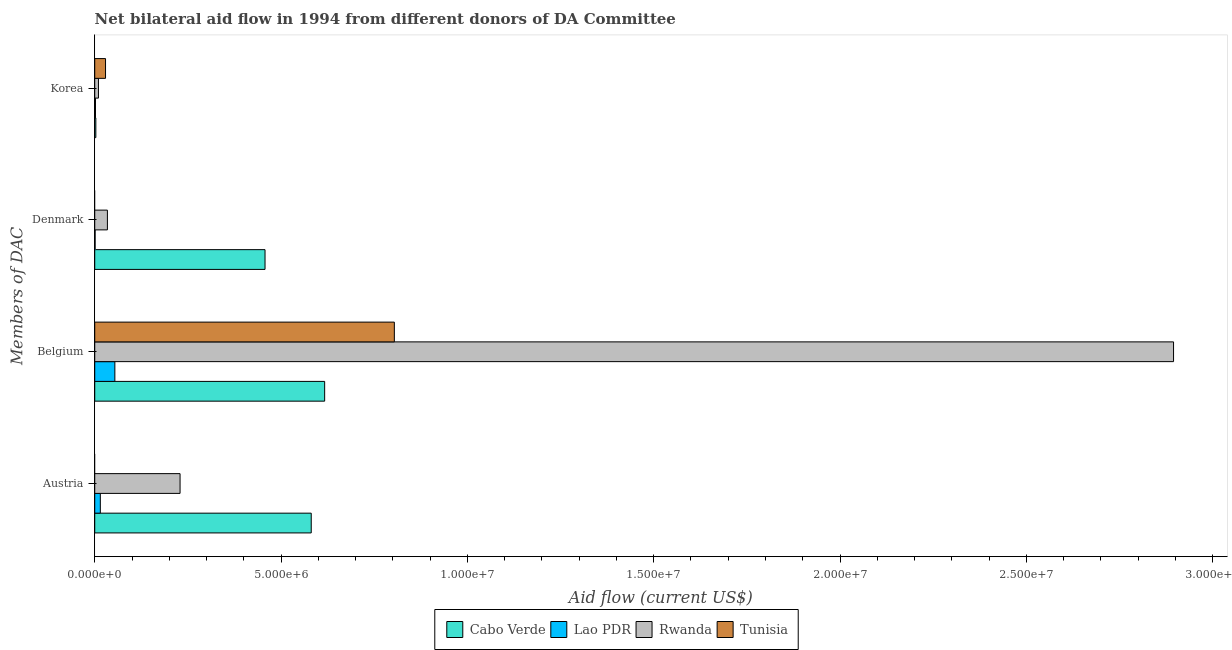Are the number of bars per tick equal to the number of legend labels?
Ensure brevity in your answer.  No. How many bars are there on the 3rd tick from the top?
Give a very brief answer. 4. How many bars are there on the 3rd tick from the bottom?
Offer a terse response. 3. What is the label of the 1st group of bars from the top?
Your answer should be compact. Korea. What is the amount of aid given by korea in Tunisia?
Provide a short and direct response. 2.90e+05. Across all countries, what is the maximum amount of aid given by austria?
Give a very brief answer. 5.81e+06. Across all countries, what is the minimum amount of aid given by denmark?
Make the answer very short. 0. In which country was the amount of aid given by austria maximum?
Offer a very short reply. Cabo Verde. What is the total amount of aid given by denmark in the graph?
Provide a short and direct response. 4.92e+06. What is the difference between the amount of aid given by korea in Rwanda and that in Tunisia?
Keep it short and to the point. -1.90e+05. What is the difference between the amount of aid given by austria in Lao PDR and the amount of aid given by korea in Tunisia?
Keep it short and to the point. -1.40e+05. What is the average amount of aid given by denmark per country?
Give a very brief answer. 1.23e+06. What is the difference between the amount of aid given by denmark and amount of aid given by belgium in Cabo Verde?
Ensure brevity in your answer.  -1.60e+06. What is the ratio of the amount of aid given by korea in Cabo Verde to that in Lao PDR?
Ensure brevity in your answer.  1.5. What is the difference between the highest and the second highest amount of aid given by denmark?
Provide a succinct answer. 4.23e+06. What is the difference between the highest and the lowest amount of aid given by austria?
Your response must be concise. 5.81e+06. In how many countries, is the amount of aid given by korea greater than the average amount of aid given by korea taken over all countries?
Offer a terse response. 1. How many bars are there?
Your response must be concise. 14. Are the values on the major ticks of X-axis written in scientific E-notation?
Keep it short and to the point. Yes. Does the graph contain any zero values?
Offer a very short reply. Yes. Does the graph contain grids?
Offer a terse response. No. Where does the legend appear in the graph?
Your response must be concise. Bottom center. How many legend labels are there?
Keep it short and to the point. 4. What is the title of the graph?
Your response must be concise. Net bilateral aid flow in 1994 from different donors of DA Committee. Does "Chile" appear as one of the legend labels in the graph?
Offer a terse response. No. What is the label or title of the X-axis?
Provide a short and direct response. Aid flow (current US$). What is the label or title of the Y-axis?
Your answer should be compact. Members of DAC. What is the Aid flow (current US$) of Cabo Verde in Austria?
Your answer should be very brief. 5.81e+06. What is the Aid flow (current US$) of Lao PDR in Austria?
Provide a succinct answer. 1.50e+05. What is the Aid flow (current US$) in Rwanda in Austria?
Make the answer very short. 2.29e+06. What is the Aid flow (current US$) of Tunisia in Austria?
Offer a very short reply. 0. What is the Aid flow (current US$) in Cabo Verde in Belgium?
Provide a succinct answer. 6.17e+06. What is the Aid flow (current US$) of Lao PDR in Belgium?
Your answer should be very brief. 5.40e+05. What is the Aid flow (current US$) of Rwanda in Belgium?
Ensure brevity in your answer.  2.90e+07. What is the Aid flow (current US$) of Tunisia in Belgium?
Make the answer very short. 8.04e+06. What is the Aid flow (current US$) of Cabo Verde in Denmark?
Provide a short and direct response. 4.57e+06. What is the Aid flow (current US$) of Lao PDR in Korea?
Give a very brief answer. 2.00e+04. What is the Aid flow (current US$) of Tunisia in Korea?
Your answer should be very brief. 2.90e+05. Across all Members of DAC, what is the maximum Aid flow (current US$) of Cabo Verde?
Offer a terse response. 6.17e+06. Across all Members of DAC, what is the maximum Aid flow (current US$) of Lao PDR?
Your answer should be very brief. 5.40e+05. Across all Members of DAC, what is the maximum Aid flow (current US$) in Rwanda?
Provide a short and direct response. 2.90e+07. Across all Members of DAC, what is the maximum Aid flow (current US$) in Tunisia?
Offer a very short reply. 8.04e+06. Across all Members of DAC, what is the minimum Aid flow (current US$) in Cabo Verde?
Provide a succinct answer. 3.00e+04. Across all Members of DAC, what is the minimum Aid flow (current US$) in Lao PDR?
Offer a terse response. 10000. Across all Members of DAC, what is the minimum Aid flow (current US$) of Tunisia?
Provide a succinct answer. 0. What is the total Aid flow (current US$) of Cabo Verde in the graph?
Your response must be concise. 1.66e+07. What is the total Aid flow (current US$) of Lao PDR in the graph?
Your answer should be compact. 7.20e+05. What is the total Aid flow (current US$) in Rwanda in the graph?
Give a very brief answer. 3.17e+07. What is the total Aid flow (current US$) in Tunisia in the graph?
Give a very brief answer. 8.33e+06. What is the difference between the Aid flow (current US$) in Cabo Verde in Austria and that in Belgium?
Ensure brevity in your answer.  -3.60e+05. What is the difference between the Aid flow (current US$) of Lao PDR in Austria and that in Belgium?
Ensure brevity in your answer.  -3.90e+05. What is the difference between the Aid flow (current US$) in Rwanda in Austria and that in Belgium?
Provide a succinct answer. -2.67e+07. What is the difference between the Aid flow (current US$) of Cabo Verde in Austria and that in Denmark?
Give a very brief answer. 1.24e+06. What is the difference between the Aid flow (current US$) of Lao PDR in Austria and that in Denmark?
Provide a short and direct response. 1.40e+05. What is the difference between the Aid flow (current US$) in Rwanda in Austria and that in Denmark?
Your answer should be compact. 1.95e+06. What is the difference between the Aid flow (current US$) of Cabo Verde in Austria and that in Korea?
Your answer should be very brief. 5.78e+06. What is the difference between the Aid flow (current US$) of Lao PDR in Austria and that in Korea?
Your answer should be very brief. 1.30e+05. What is the difference between the Aid flow (current US$) in Rwanda in Austria and that in Korea?
Offer a terse response. 2.19e+06. What is the difference between the Aid flow (current US$) of Cabo Verde in Belgium and that in Denmark?
Your response must be concise. 1.60e+06. What is the difference between the Aid flow (current US$) of Lao PDR in Belgium and that in Denmark?
Provide a succinct answer. 5.30e+05. What is the difference between the Aid flow (current US$) of Rwanda in Belgium and that in Denmark?
Give a very brief answer. 2.86e+07. What is the difference between the Aid flow (current US$) of Cabo Verde in Belgium and that in Korea?
Your response must be concise. 6.14e+06. What is the difference between the Aid flow (current US$) of Lao PDR in Belgium and that in Korea?
Keep it short and to the point. 5.20e+05. What is the difference between the Aid flow (current US$) of Rwanda in Belgium and that in Korea?
Your response must be concise. 2.88e+07. What is the difference between the Aid flow (current US$) in Tunisia in Belgium and that in Korea?
Your response must be concise. 7.75e+06. What is the difference between the Aid flow (current US$) of Cabo Verde in Denmark and that in Korea?
Make the answer very short. 4.54e+06. What is the difference between the Aid flow (current US$) of Lao PDR in Denmark and that in Korea?
Ensure brevity in your answer.  -10000. What is the difference between the Aid flow (current US$) of Rwanda in Denmark and that in Korea?
Provide a short and direct response. 2.40e+05. What is the difference between the Aid flow (current US$) in Cabo Verde in Austria and the Aid flow (current US$) in Lao PDR in Belgium?
Keep it short and to the point. 5.27e+06. What is the difference between the Aid flow (current US$) of Cabo Verde in Austria and the Aid flow (current US$) of Rwanda in Belgium?
Offer a very short reply. -2.31e+07. What is the difference between the Aid flow (current US$) of Cabo Verde in Austria and the Aid flow (current US$) of Tunisia in Belgium?
Give a very brief answer. -2.23e+06. What is the difference between the Aid flow (current US$) of Lao PDR in Austria and the Aid flow (current US$) of Rwanda in Belgium?
Offer a terse response. -2.88e+07. What is the difference between the Aid flow (current US$) of Lao PDR in Austria and the Aid flow (current US$) of Tunisia in Belgium?
Your answer should be very brief. -7.89e+06. What is the difference between the Aid flow (current US$) of Rwanda in Austria and the Aid flow (current US$) of Tunisia in Belgium?
Ensure brevity in your answer.  -5.75e+06. What is the difference between the Aid flow (current US$) in Cabo Verde in Austria and the Aid flow (current US$) in Lao PDR in Denmark?
Ensure brevity in your answer.  5.80e+06. What is the difference between the Aid flow (current US$) of Cabo Verde in Austria and the Aid flow (current US$) of Rwanda in Denmark?
Provide a short and direct response. 5.47e+06. What is the difference between the Aid flow (current US$) of Lao PDR in Austria and the Aid flow (current US$) of Rwanda in Denmark?
Provide a short and direct response. -1.90e+05. What is the difference between the Aid flow (current US$) in Cabo Verde in Austria and the Aid flow (current US$) in Lao PDR in Korea?
Make the answer very short. 5.79e+06. What is the difference between the Aid flow (current US$) of Cabo Verde in Austria and the Aid flow (current US$) of Rwanda in Korea?
Keep it short and to the point. 5.71e+06. What is the difference between the Aid flow (current US$) of Cabo Verde in Austria and the Aid flow (current US$) of Tunisia in Korea?
Keep it short and to the point. 5.52e+06. What is the difference between the Aid flow (current US$) of Lao PDR in Austria and the Aid flow (current US$) of Tunisia in Korea?
Ensure brevity in your answer.  -1.40e+05. What is the difference between the Aid flow (current US$) in Rwanda in Austria and the Aid flow (current US$) in Tunisia in Korea?
Give a very brief answer. 2.00e+06. What is the difference between the Aid flow (current US$) of Cabo Verde in Belgium and the Aid flow (current US$) of Lao PDR in Denmark?
Keep it short and to the point. 6.16e+06. What is the difference between the Aid flow (current US$) in Cabo Verde in Belgium and the Aid flow (current US$) in Rwanda in Denmark?
Ensure brevity in your answer.  5.83e+06. What is the difference between the Aid flow (current US$) of Cabo Verde in Belgium and the Aid flow (current US$) of Lao PDR in Korea?
Make the answer very short. 6.15e+06. What is the difference between the Aid flow (current US$) in Cabo Verde in Belgium and the Aid flow (current US$) in Rwanda in Korea?
Provide a short and direct response. 6.07e+06. What is the difference between the Aid flow (current US$) in Cabo Verde in Belgium and the Aid flow (current US$) in Tunisia in Korea?
Offer a very short reply. 5.88e+06. What is the difference between the Aid flow (current US$) in Lao PDR in Belgium and the Aid flow (current US$) in Rwanda in Korea?
Offer a very short reply. 4.40e+05. What is the difference between the Aid flow (current US$) of Lao PDR in Belgium and the Aid flow (current US$) of Tunisia in Korea?
Your response must be concise. 2.50e+05. What is the difference between the Aid flow (current US$) of Rwanda in Belgium and the Aid flow (current US$) of Tunisia in Korea?
Provide a succinct answer. 2.87e+07. What is the difference between the Aid flow (current US$) of Cabo Verde in Denmark and the Aid flow (current US$) of Lao PDR in Korea?
Make the answer very short. 4.55e+06. What is the difference between the Aid flow (current US$) in Cabo Verde in Denmark and the Aid flow (current US$) in Rwanda in Korea?
Keep it short and to the point. 4.47e+06. What is the difference between the Aid flow (current US$) of Cabo Verde in Denmark and the Aid flow (current US$) of Tunisia in Korea?
Make the answer very short. 4.28e+06. What is the difference between the Aid flow (current US$) in Lao PDR in Denmark and the Aid flow (current US$) in Tunisia in Korea?
Your answer should be very brief. -2.80e+05. What is the difference between the Aid flow (current US$) in Rwanda in Denmark and the Aid flow (current US$) in Tunisia in Korea?
Provide a short and direct response. 5.00e+04. What is the average Aid flow (current US$) in Cabo Verde per Members of DAC?
Make the answer very short. 4.14e+06. What is the average Aid flow (current US$) of Lao PDR per Members of DAC?
Provide a succinct answer. 1.80e+05. What is the average Aid flow (current US$) of Rwanda per Members of DAC?
Your response must be concise. 7.92e+06. What is the average Aid flow (current US$) in Tunisia per Members of DAC?
Make the answer very short. 2.08e+06. What is the difference between the Aid flow (current US$) of Cabo Verde and Aid flow (current US$) of Lao PDR in Austria?
Your answer should be very brief. 5.66e+06. What is the difference between the Aid flow (current US$) in Cabo Verde and Aid flow (current US$) in Rwanda in Austria?
Your answer should be compact. 3.52e+06. What is the difference between the Aid flow (current US$) in Lao PDR and Aid flow (current US$) in Rwanda in Austria?
Provide a short and direct response. -2.14e+06. What is the difference between the Aid flow (current US$) in Cabo Verde and Aid flow (current US$) in Lao PDR in Belgium?
Ensure brevity in your answer.  5.63e+06. What is the difference between the Aid flow (current US$) in Cabo Verde and Aid flow (current US$) in Rwanda in Belgium?
Give a very brief answer. -2.28e+07. What is the difference between the Aid flow (current US$) in Cabo Verde and Aid flow (current US$) in Tunisia in Belgium?
Provide a succinct answer. -1.87e+06. What is the difference between the Aid flow (current US$) in Lao PDR and Aid flow (current US$) in Rwanda in Belgium?
Your answer should be very brief. -2.84e+07. What is the difference between the Aid flow (current US$) in Lao PDR and Aid flow (current US$) in Tunisia in Belgium?
Provide a succinct answer. -7.50e+06. What is the difference between the Aid flow (current US$) of Rwanda and Aid flow (current US$) of Tunisia in Belgium?
Provide a succinct answer. 2.09e+07. What is the difference between the Aid flow (current US$) in Cabo Verde and Aid flow (current US$) in Lao PDR in Denmark?
Provide a short and direct response. 4.56e+06. What is the difference between the Aid flow (current US$) in Cabo Verde and Aid flow (current US$) in Rwanda in Denmark?
Provide a succinct answer. 4.23e+06. What is the difference between the Aid flow (current US$) of Lao PDR and Aid flow (current US$) of Rwanda in Denmark?
Your response must be concise. -3.30e+05. What is the ratio of the Aid flow (current US$) in Cabo Verde in Austria to that in Belgium?
Ensure brevity in your answer.  0.94. What is the ratio of the Aid flow (current US$) of Lao PDR in Austria to that in Belgium?
Provide a succinct answer. 0.28. What is the ratio of the Aid flow (current US$) of Rwanda in Austria to that in Belgium?
Offer a very short reply. 0.08. What is the ratio of the Aid flow (current US$) of Cabo Verde in Austria to that in Denmark?
Provide a short and direct response. 1.27. What is the ratio of the Aid flow (current US$) of Rwanda in Austria to that in Denmark?
Offer a very short reply. 6.74. What is the ratio of the Aid flow (current US$) in Cabo Verde in Austria to that in Korea?
Ensure brevity in your answer.  193.67. What is the ratio of the Aid flow (current US$) of Rwanda in Austria to that in Korea?
Your answer should be very brief. 22.9. What is the ratio of the Aid flow (current US$) of Cabo Verde in Belgium to that in Denmark?
Your answer should be compact. 1.35. What is the ratio of the Aid flow (current US$) in Rwanda in Belgium to that in Denmark?
Offer a very short reply. 85.15. What is the ratio of the Aid flow (current US$) of Cabo Verde in Belgium to that in Korea?
Provide a short and direct response. 205.67. What is the ratio of the Aid flow (current US$) in Lao PDR in Belgium to that in Korea?
Keep it short and to the point. 27. What is the ratio of the Aid flow (current US$) of Rwanda in Belgium to that in Korea?
Your answer should be compact. 289.5. What is the ratio of the Aid flow (current US$) of Tunisia in Belgium to that in Korea?
Your answer should be very brief. 27.72. What is the ratio of the Aid flow (current US$) in Cabo Verde in Denmark to that in Korea?
Provide a succinct answer. 152.33. What is the ratio of the Aid flow (current US$) of Lao PDR in Denmark to that in Korea?
Your response must be concise. 0.5. What is the ratio of the Aid flow (current US$) in Rwanda in Denmark to that in Korea?
Your answer should be compact. 3.4. What is the difference between the highest and the second highest Aid flow (current US$) in Cabo Verde?
Offer a very short reply. 3.60e+05. What is the difference between the highest and the second highest Aid flow (current US$) of Lao PDR?
Your answer should be compact. 3.90e+05. What is the difference between the highest and the second highest Aid flow (current US$) in Rwanda?
Give a very brief answer. 2.67e+07. What is the difference between the highest and the lowest Aid flow (current US$) in Cabo Verde?
Offer a very short reply. 6.14e+06. What is the difference between the highest and the lowest Aid flow (current US$) of Lao PDR?
Ensure brevity in your answer.  5.30e+05. What is the difference between the highest and the lowest Aid flow (current US$) in Rwanda?
Provide a succinct answer. 2.88e+07. What is the difference between the highest and the lowest Aid flow (current US$) of Tunisia?
Make the answer very short. 8.04e+06. 